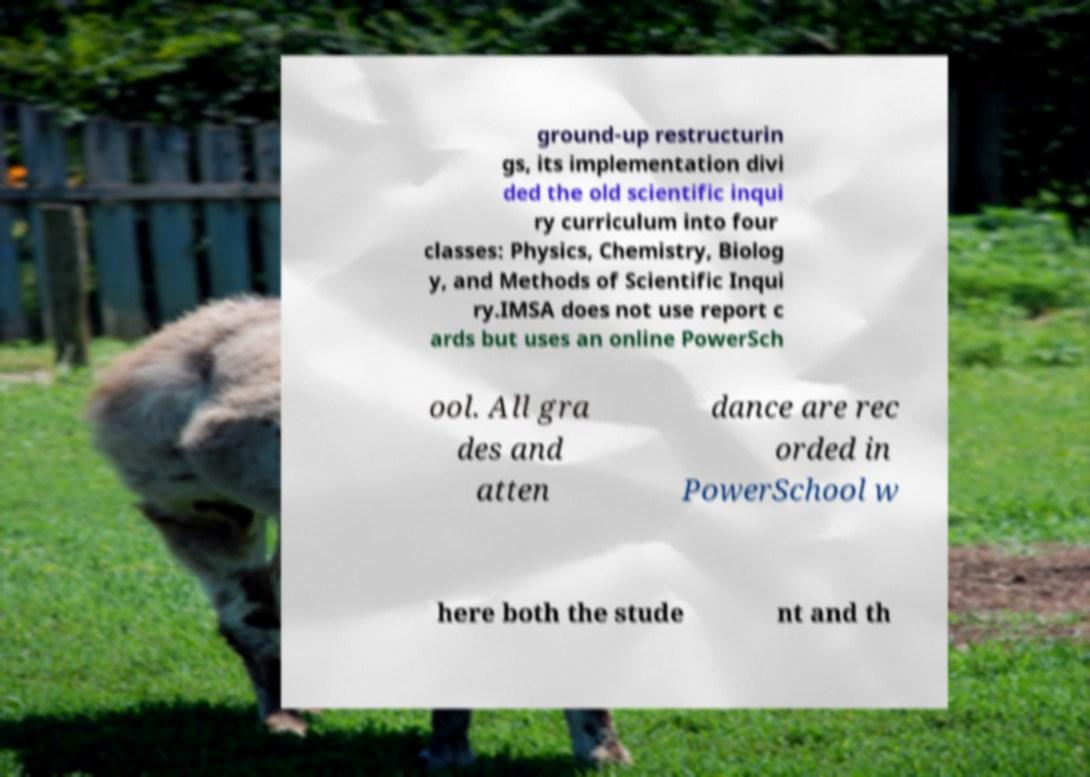I need the written content from this picture converted into text. Can you do that? ground-up restructurin gs, its implementation divi ded the old scientific inqui ry curriculum into four classes: Physics, Chemistry, Biolog y, and Methods of Scientific Inqui ry.IMSA does not use report c ards but uses an online PowerSch ool. All gra des and atten dance are rec orded in PowerSchool w here both the stude nt and th 